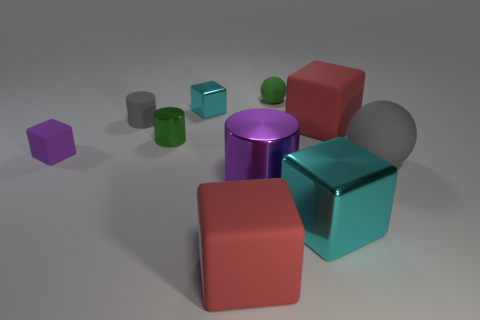Do the red thing behind the big cyan shiny cube and the large cyan object have the same shape?
Provide a short and direct response. Yes. The rubber object that is the same color as the big metal cylinder is what shape?
Keep it short and to the point. Cube. Is the color of the tiny metallic block the same as the large rubber cube behind the gray sphere?
Keep it short and to the point. No. What is the size of the other cylinder that is the same material as the purple cylinder?
Your answer should be very brief. Small. There is another shiny cube that is the same color as the small metal block; what is its size?
Your response must be concise. Large. Is the color of the matte cylinder the same as the tiny rubber ball?
Keep it short and to the point. No. Are there any shiny cubes in front of the cyan block that is behind the metallic block in front of the big rubber sphere?
Your response must be concise. Yes. What number of green matte blocks have the same size as the green ball?
Keep it short and to the point. 0. There is a rubber sphere behind the tiny rubber block; is its size the same as the red matte thing in front of the small green metal cylinder?
Provide a succinct answer. No. What shape is the rubber thing that is both behind the green cylinder and right of the big cyan thing?
Offer a very short reply. Cube. 